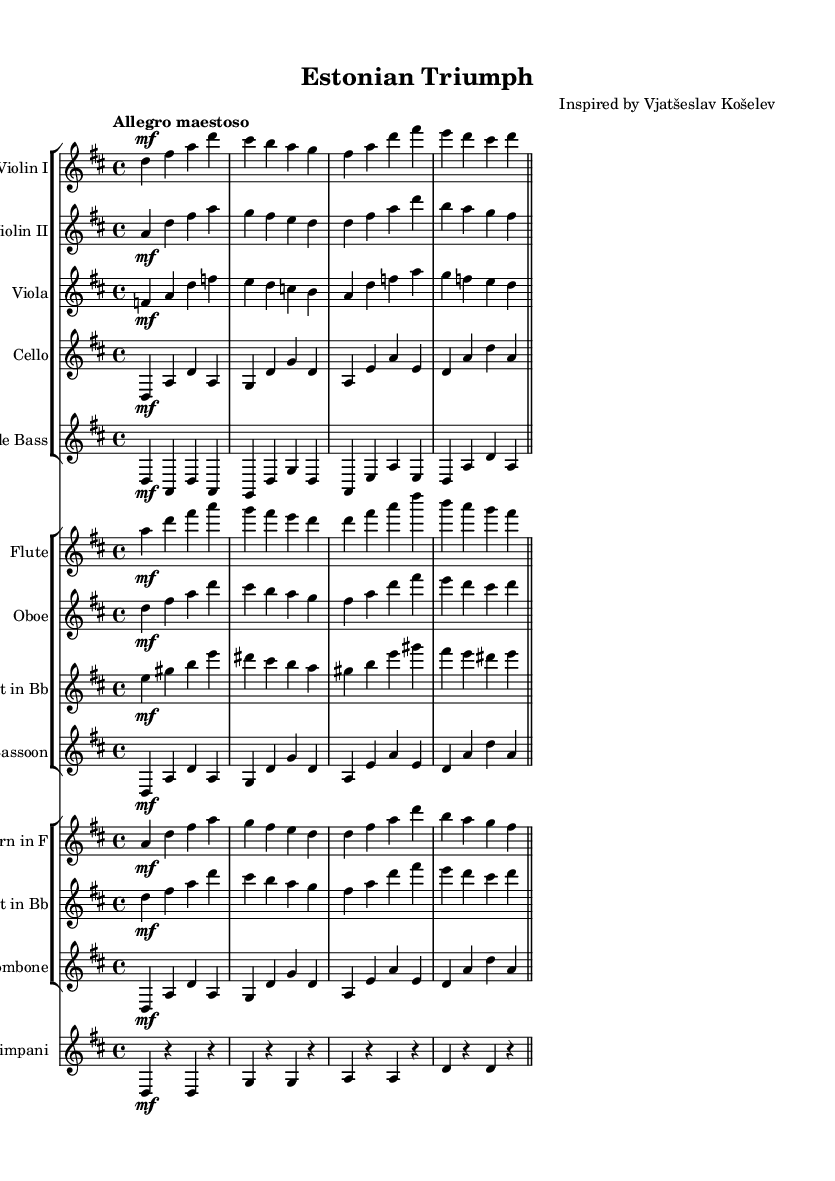What is the key signature of this music? The key signature is D major, which is indicated by two sharps (F# and C#) in the key signature at the beginning of the staff.
Answer: D major What is the time signature of this music? The time signature is 4/4, which is shown at the beginning of the score as two stacked numbers, indicating four beats in a measure and a quarter note gets one beat.
Answer: 4/4 What is the tempo marking for this piece? The tempo marking at the beginning of the score states "Allegro maestoso," indicating a fast and majestic style of play.
Answer: Allegro maestoso What is the instrumentation of this piece? The score includes strings, woodwinds, brass, and percussion, specifically listing Violins, Viola, Cello, Double Bass, Flute, Oboe, Clarinet, Bassoon, Horn, Trumpet, Trombone, and Timpani.
Answer: Strings, Woodwinds, Brass, Percussion What is the dynamic marking for the main theme in the violins? The main theme in the violins is marked with "mf," indicating a mezzo-forte dynamic, which suggests a moderately loud volume.
Answer: Mezzo-forte How does the orchestration contribute to the theme of triumph and perseverance? The orchestration features rich harmonies and a full texture that combines the various instrument families, enhancing the celebratory and uplifting nature of the theme, with vigorous rhythms that evoke a sense of determination.
Answer: Rich harmonies and full texture Which instruments are responsible for the melody primarily? The melody is primarily played by the first violins and is complemented by the flute and the oboe, creating a bright and airy character.
Answer: Violins, Flute, Oboe 